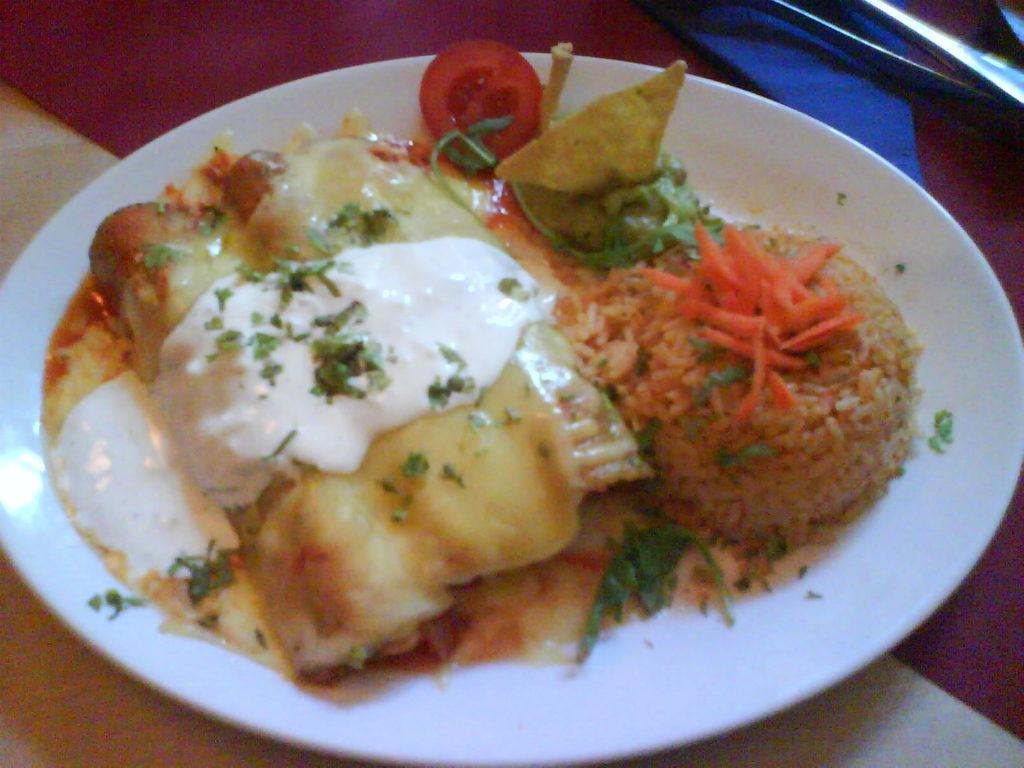What color is the plate that is visible in the image? The plate in the image is white. What is on the plate in the image? There is food on the plate in the image. What type of arch can be seen in the background of the image? There is no arch present in the image; it only features a white color plate with food on it. 